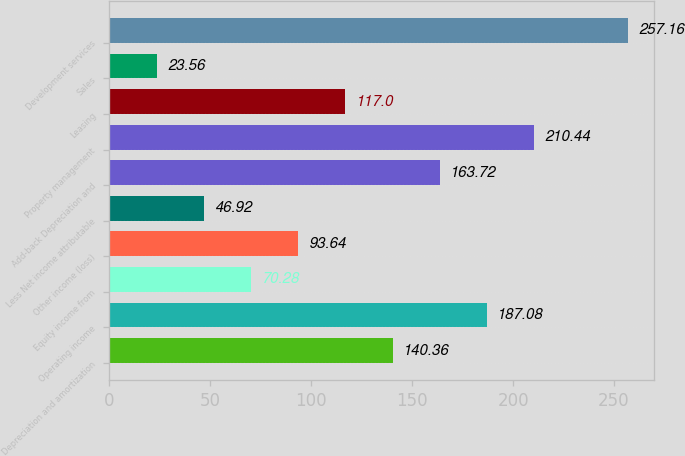Convert chart. <chart><loc_0><loc_0><loc_500><loc_500><bar_chart><fcel>Depreciation and amortization<fcel>Operating income<fcel>Equity income from<fcel>Other income (loss)<fcel>Less Net income attributable<fcel>Add-back Depreciation and<fcel>Property management<fcel>Leasing<fcel>Sales<fcel>Development services<nl><fcel>140.36<fcel>187.08<fcel>70.28<fcel>93.64<fcel>46.92<fcel>163.72<fcel>210.44<fcel>117<fcel>23.56<fcel>257.16<nl></chart> 